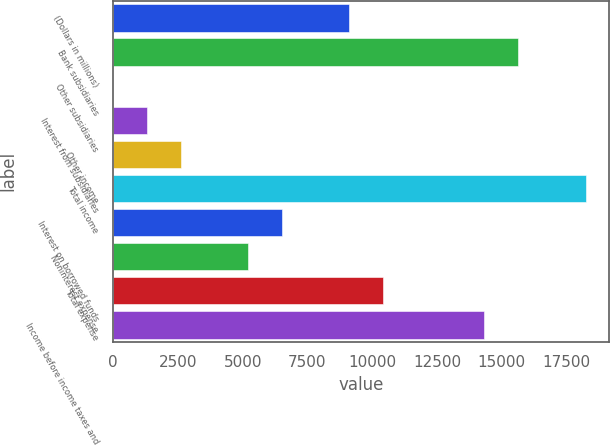Convert chart. <chart><loc_0><loc_0><loc_500><loc_500><bar_chart><fcel>(Dollars in millions)<fcel>Bank subsidiaries<fcel>Other subsidiaries<fcel>Interest from subsidiaries<fcel>Other income<fcel>Total income<fcel>Interest on borrowed funds<fcel>Noninterest expense<fcel>Total expense<fcel>Income before income taxes and<nl><fcel>9119.1<fcel>15625.6<fcel>10<fcel>1311.3<fcel>2612.6<fcel>18228.2<fcel>6516.5<fcel>5215.2<fcel>10420.4<fcel>14324.3<nl></chart> 